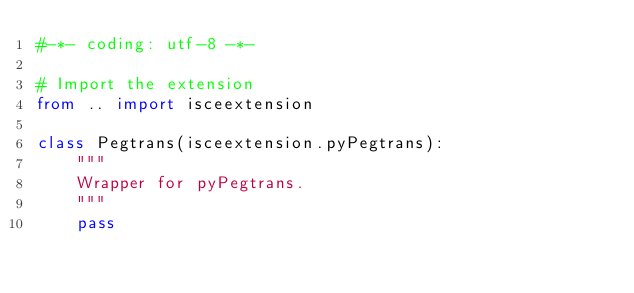Convert code to text. <code><loc_0><loc_0><loc_500><loc_500><_Python_>#-*- coding: utf-8 -*-

# Import the extension
from .. import isceextension

class Pegtrans(isceextension.pyPegtrans):
    """
    Wrapper for pyPegtrans.
    """
    pass

</code> 